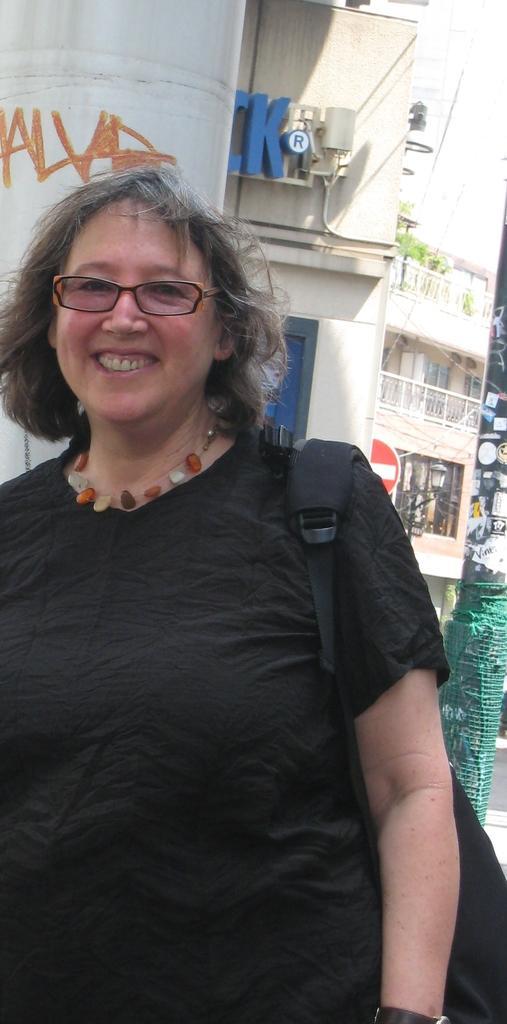How would you summarize this image in a sentence or two? In this picture we can see a woman, she is smiling, and she wore a bag and spectacles, in the background we can see few buildings and plants. 